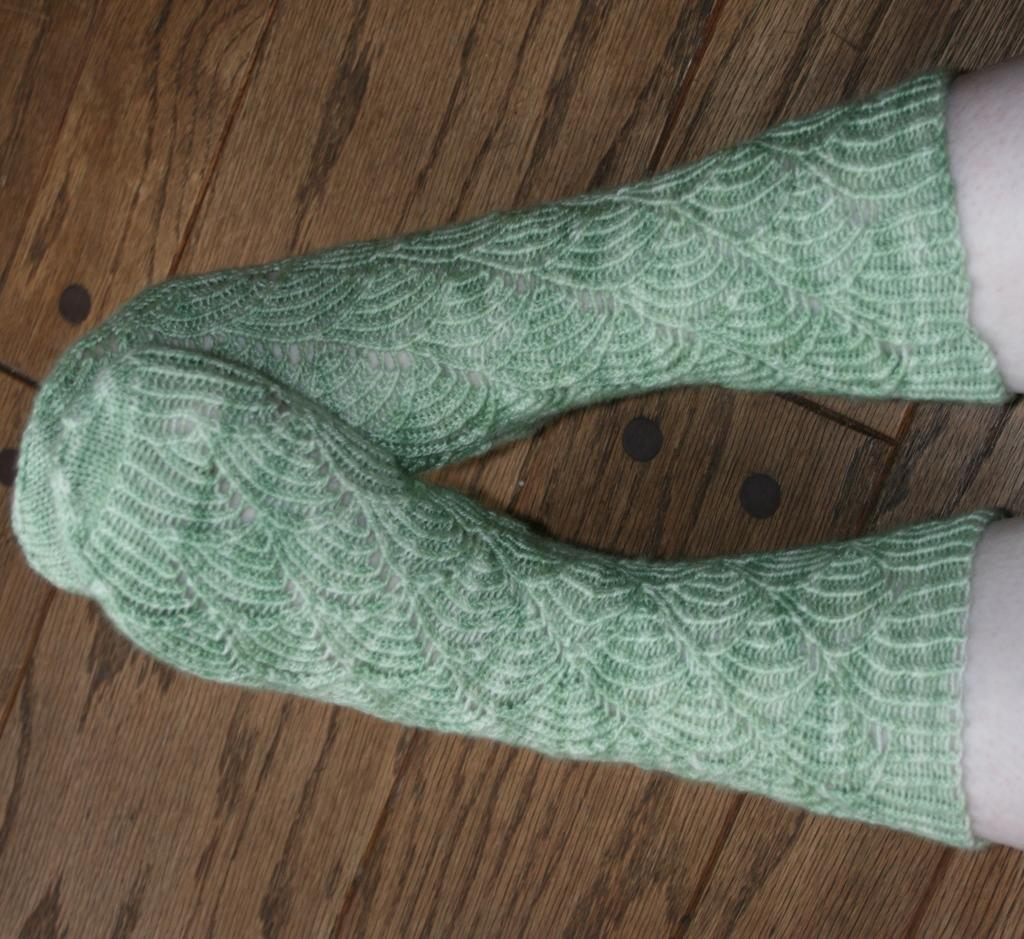What body part is visible in the image? There are legs of a person visible in the image. What are the legs wearing? The legs have socks on them. What color are the socks? The socks are green in color. How many fingers does the person have on their hand in the image? There is no hand visible in the image, only the legs of the person are shown. 